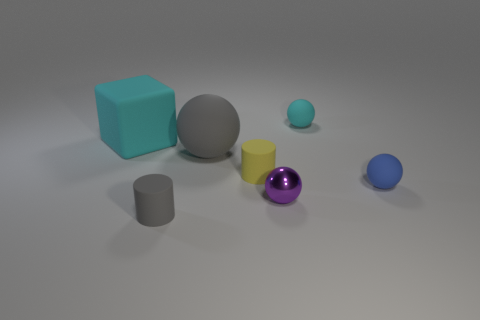Add 1 tiny purple objects. How many objects exist? 8 Subtract all cylinders. How many objects are left? 5 Add 7 small rubber spheres. How many small rubber spheres are left? 9 Add 1 tiny matte cylinders. How many tiny matte cylinders exist? 3 Subtract 0 purple cylinders. How many objects are left? 7 Subtract all cyan cubes. Subtract all large brown spheres. How many objects are left? 6 